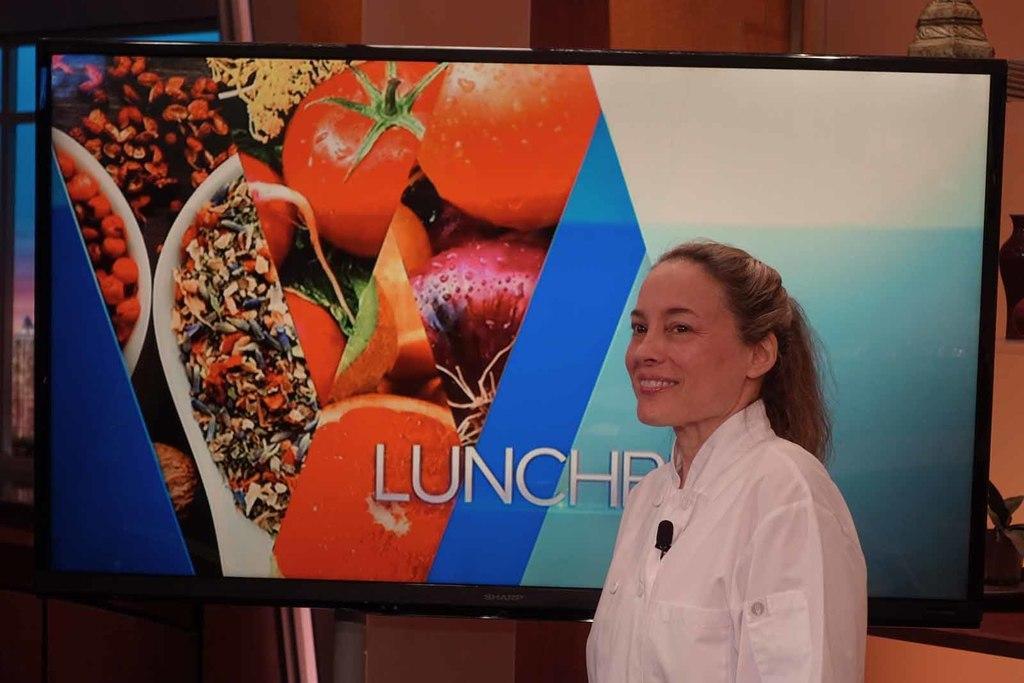Could you give a brief overview of what you see in this image? In the center of the image there is a lady standing. In the background of the image there is a tv screen. 